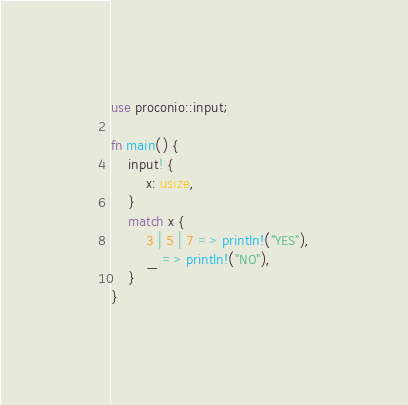Convert code to text. <code><loc_0><loc_0><loc_500><loc_500><_Rust_>use proconio::input;

fn main() {
    input! {
        x: usize,
    }
    match x {
        3 | 5 | 7 => println!("YES"),
        _ => println!("NO"),
    }
}
</code> 